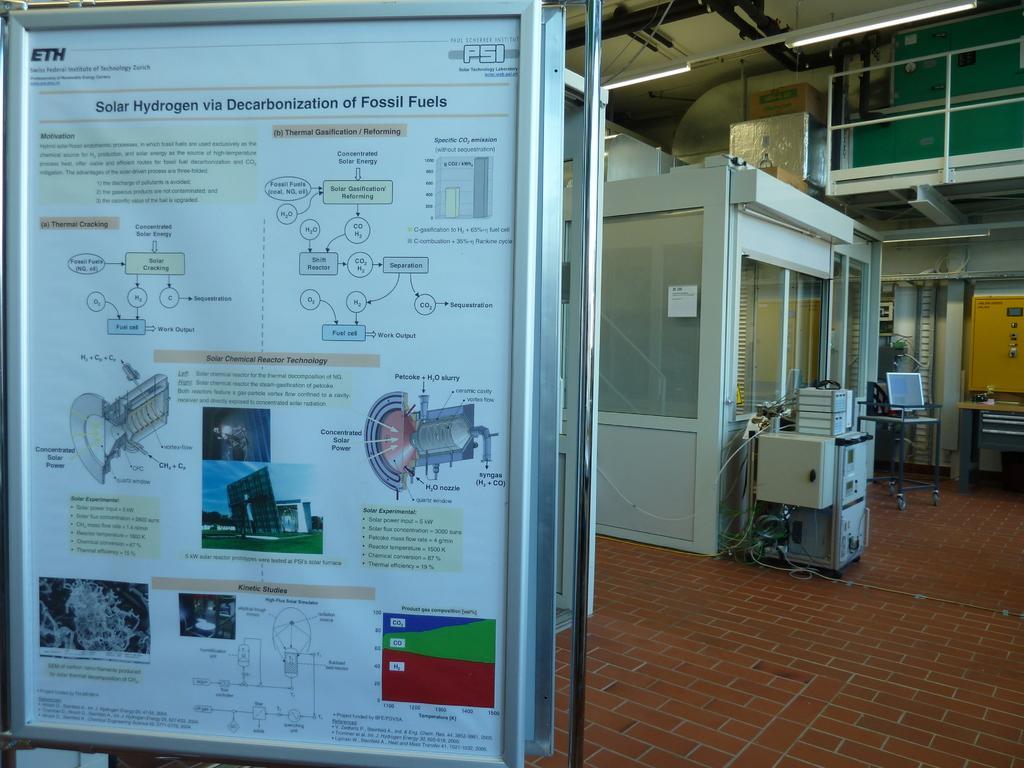In one or two sentences, can you explain what this image depicts? In this picture, it seems like a poster on which there are pictures and text, it seems like cabins, machine, light and other objects in the background. 